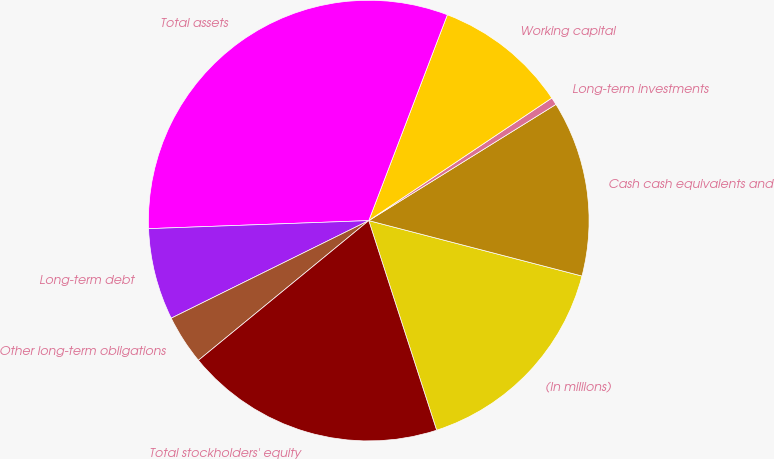<chart> <loc_0><loc_0><loc_500><loc_500><pie_chart><fcel>(In millions)<fcel>Cash cash equivalents and<fcel>Long-term investments<fcel>Working capital<fcel>Total assets<fcel>Long-term debt<fcel>Other long-term obligations<fcel>Total stockholders' equity<nl><fcel>15.97%<fcel>12.89%<fcel>0.55%<fcel>9.8%<fcel>31.39%<fcel>6.72%<fcel>3.63%<fcel>19.05%<nl></chart> 